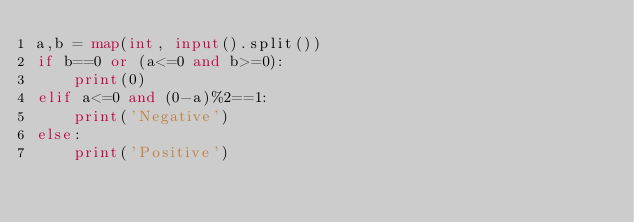Convert code to text. <code><loc_0><loc_0><loc_500><loc_500><_Python_>a,b = map(int, input().split())
if b==0 or (a<=0 and b>=0):
    print(0)
elif a<=0 and (0-a)%2==1:
    print('Negative')
else:
    print('Positive')</code> 